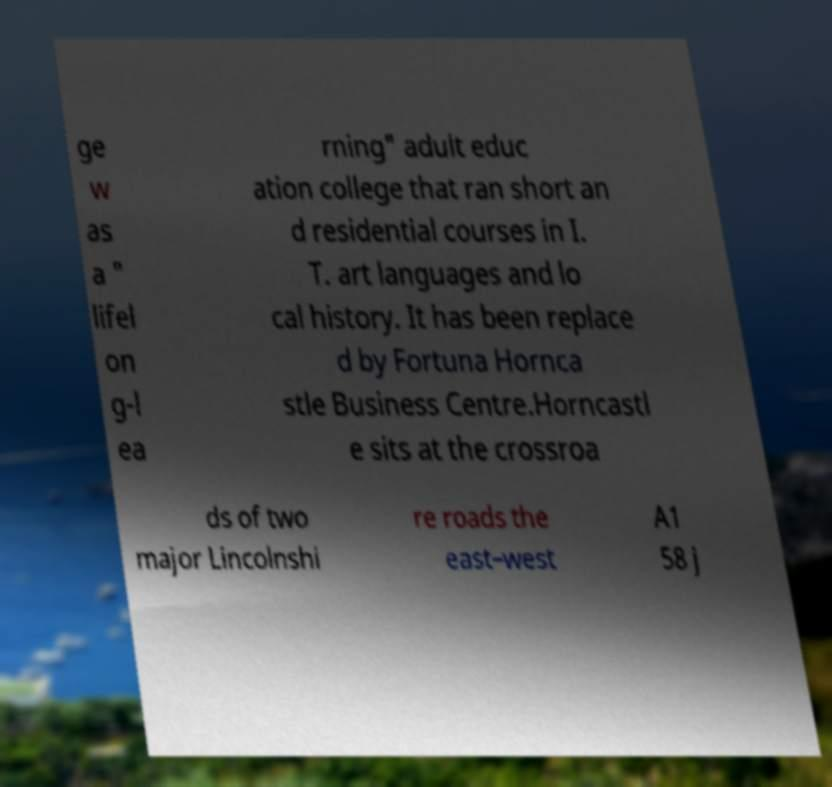For documentation purposes, I need the text within this image transcribed. Could you provide that? ge w as a " lifel on g-l ea rning" adult educ ation college that ran short an d residential courses in I. T. art languages and lo cal history. It has been replace d by Fortuna Hornca stle Business Centre.Horncastl e sits at the crossroa ds of two major Lincolnshi re roads the east–west A1 58 j 